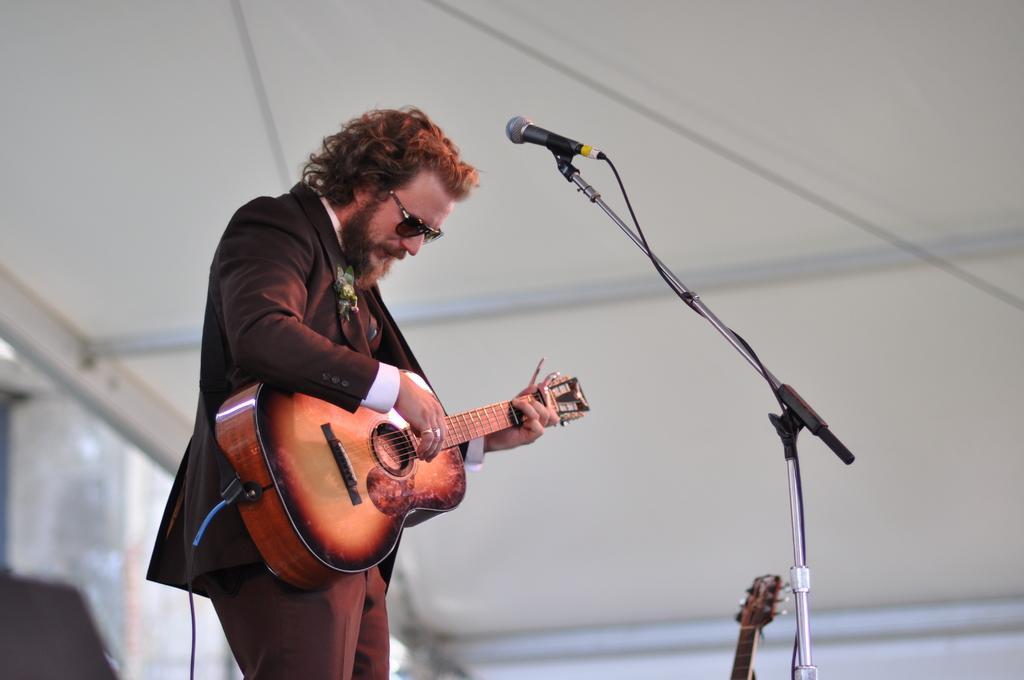In one or two sentences, can you explain what this image depicts? In this picture a man is highlighted. He wore brown colour goggles. We can see a guitar in his hands. This is a mike. He wore a brown colour attire. 